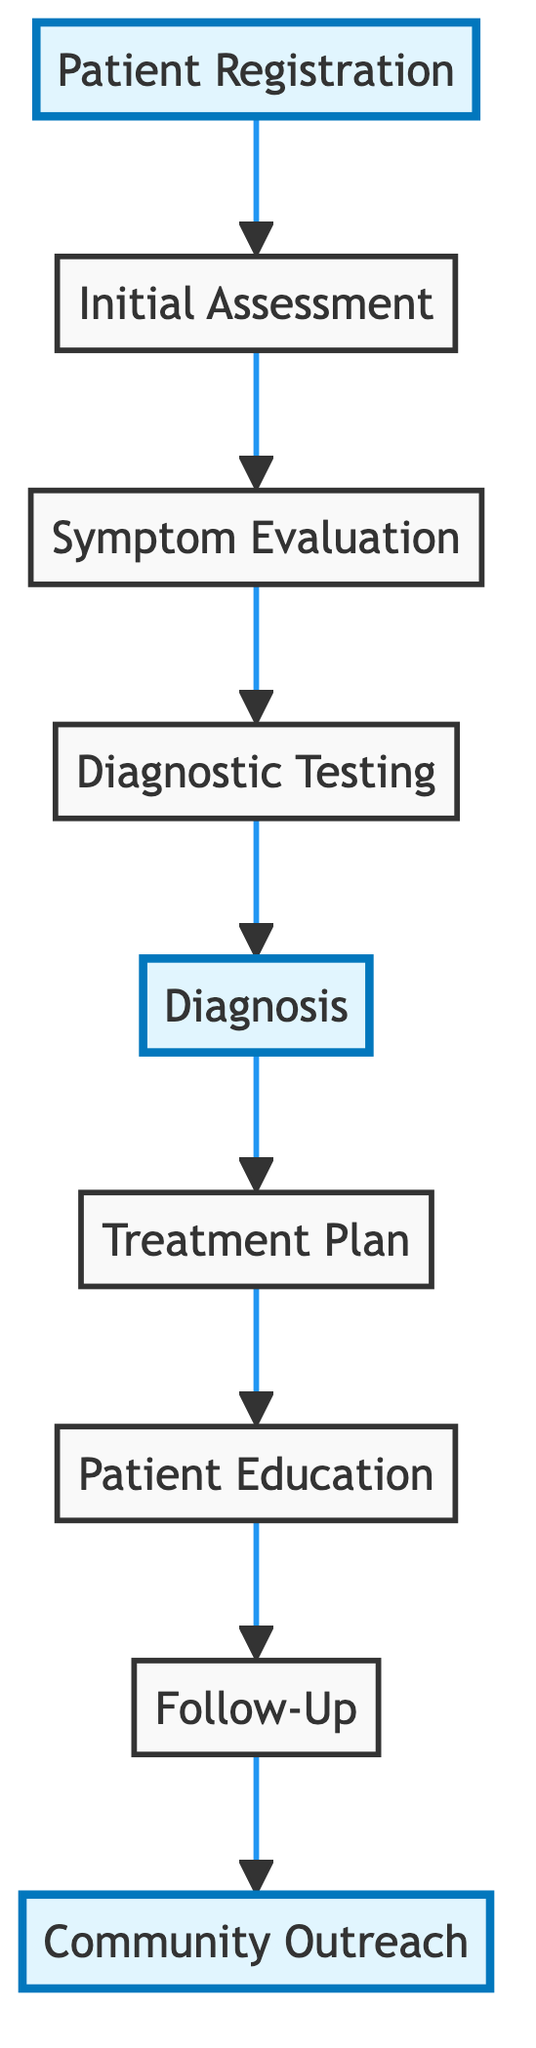What is the first step in the process? The first step in the process is indicated as "Patient Registration" at the top of the flowchart. This is the starting point before any other steps are taken.
Answer: Patient Registration How many steps are in the process? By counting the nodes in the diagram, there are a total of nine distinct steps outlined in the flowchart.
Answer: 9 What is the last step in the sequence? The last step in the flowchart is "Community Outreach," which appears at the bottom after "Follow-Up," concluding the process.
Answer: Community Outreach What directly follows the "Diagnostic Testing"? Looking at the flowchart, the step that directly follows "Diagnostic Testing" is "Diagnosis," which interprets the results of the tests.
Answer: Diagnosis Which step includes education about hygiene practices? The step that provides education on hygiene practices is "Patient Education," as described in the flowchart. This emphasizes the importance of hygiene in preventing infections.
Answer: Patient Education What is the relationship between "Diagnosis" and "Treatment Plan"? "Diagnosis" is a prerequisite to the "Treatment Plan," meaning that a diagnosis must be established before a treatment can be prescribed. This shows the flow of information from identifying the disease to planning its treatment.
Answer: Diagnosis to Treatment Plan What step includes scheduling follow-up appointments? The "Follow-Up" step includes scheduling future appointments to monitor the patient’s progress after treatment has begun. This emphasizes continuity of care.
Answer: Follow-Up How are symptoms evaluated in the process? Symptoms are evaluated during the "Symptom Evaluation" step, which involves documenting the presenting symptoms and their duration before moving on to diagnostic testing.
Answer: Symptom Evaluation Which steps are highlighted in the flowchart? The highlighted steps in the flowchart are "Patient Registration," "Diagnosis," and "Community Outreach," indicating their importance in the overall process.
Answer: Patient Registration, Diagnosis, Community Outreach 